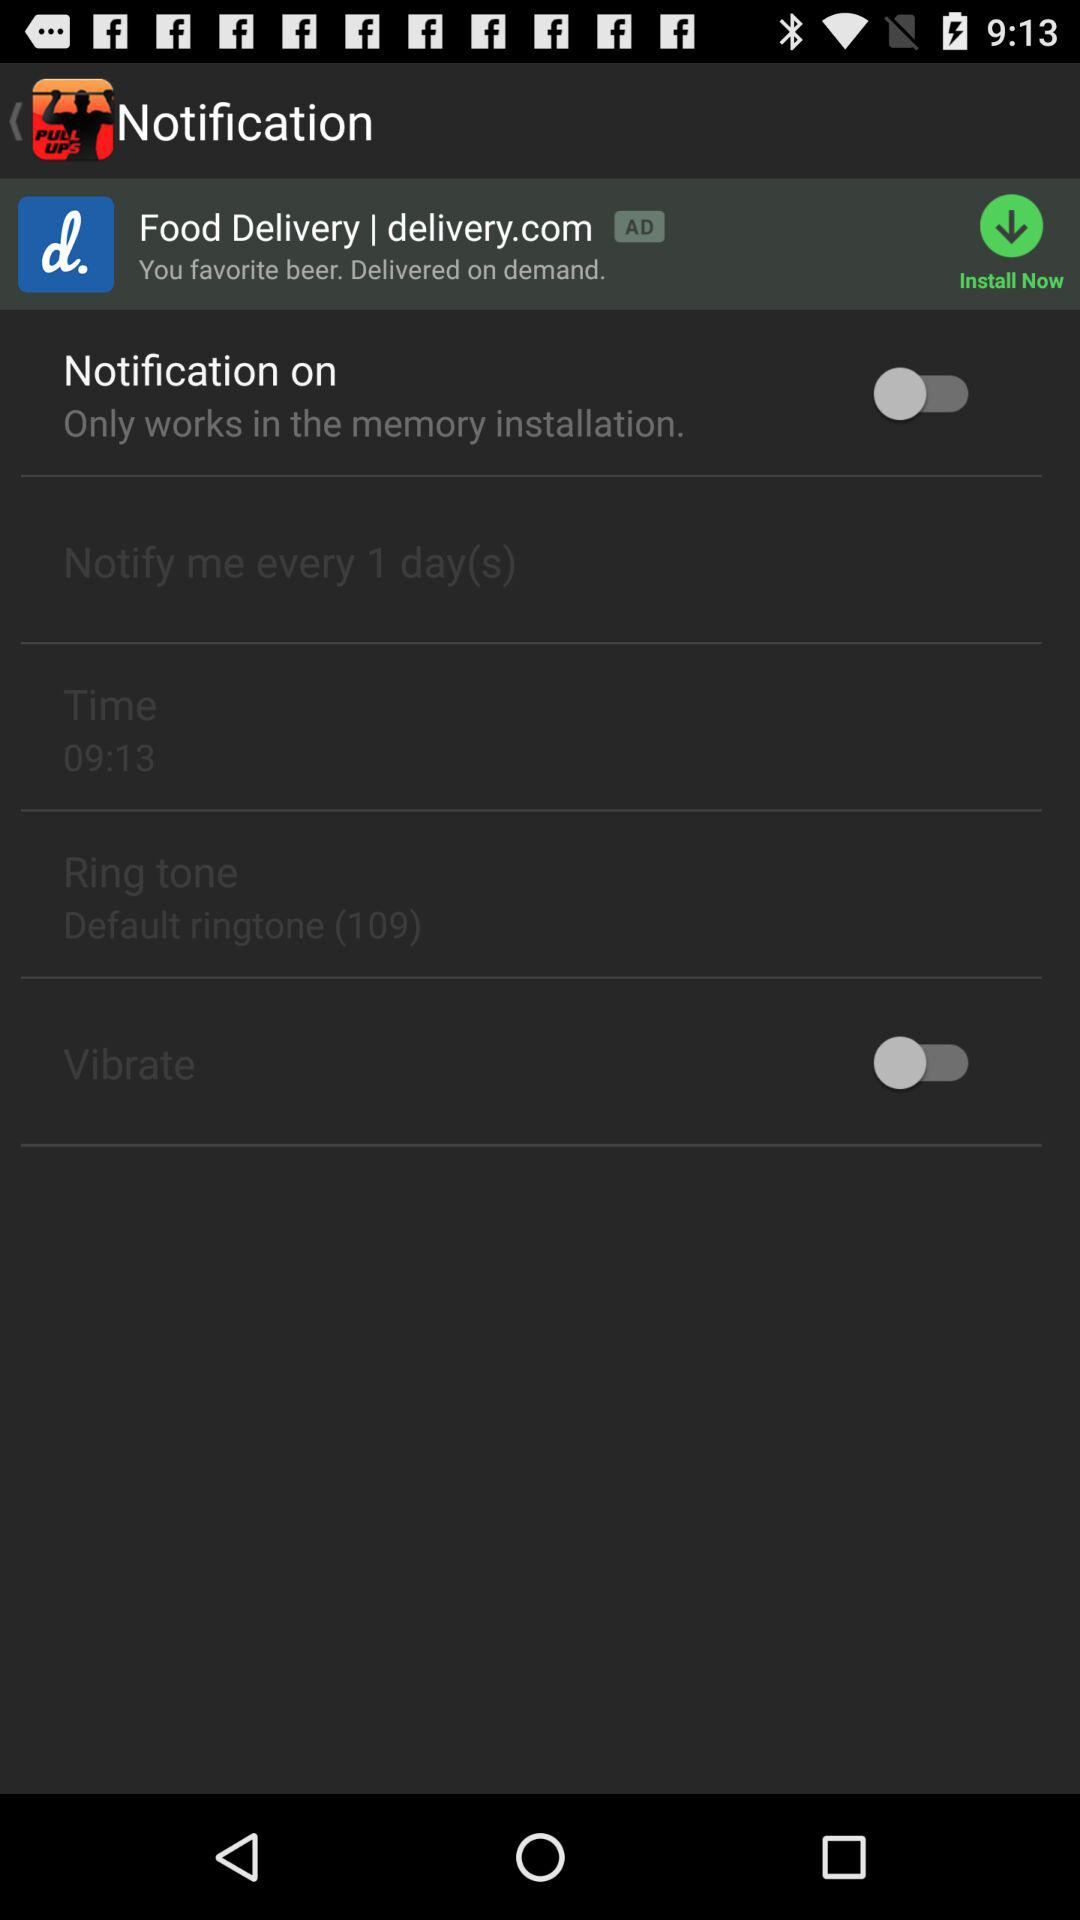What is the selected ringtone? The selected ringtone is "Default ringtone (109)". 